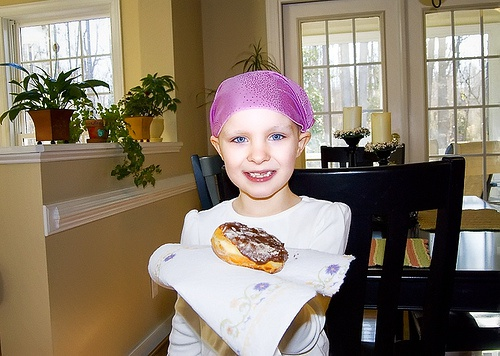Describe the objects in this image and their specific colors. I can see chair in olive, black, gray, and brown tones, people in olive, lightgray, lightpink, and violet tones, dining table in olive, black, lightgray, and darkgray tones, potted plant in olive, black, white, maroon, and darkgray tones, and donut in olive, lightgray, maroon, darkgray, and orange tones in this image. 